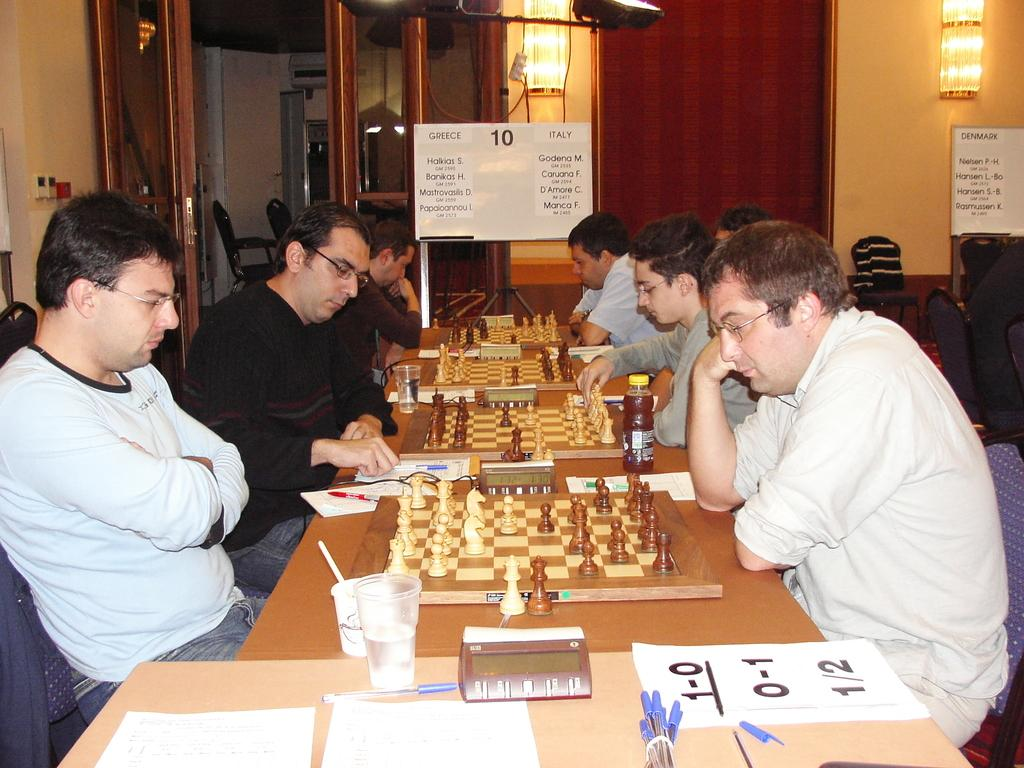What are the people in the image doing? The people in the image are playing chess. Where is the chess board located? The chess board is on a table. What else can be seen on the table? There are cups and bottles on the table. What type of bread is being used as a chess piece in the image? There is no bread present in the image, and all the chess pieces are standard chess pieces. 